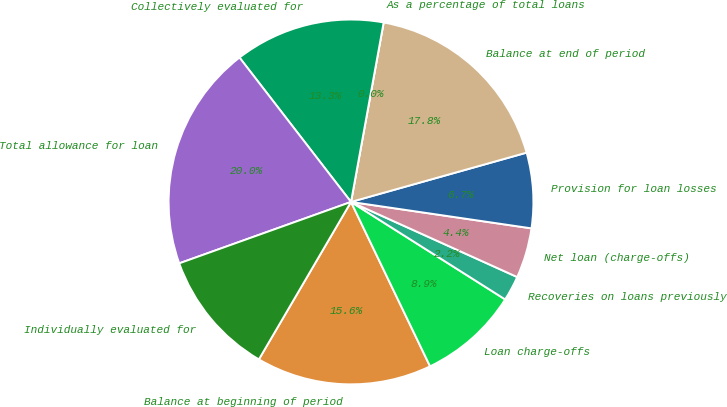<chart> <loc_0><loc_0><loc_500><loc_500><pie_chart><fcel>Balance at beginning of period<fcel>Loan charge-offs<fcel>Recoveries on loans previously<fcel>Net loan (charge-offs)<fcel>Provision for loan losses<fcel>Balance at end of period<fcel>As a percentage of total loans<fcel>Collectively evaluated for<fcel>Total allowance for loan<fcel>Individually evaluated for<nl><fcel>15.56%<fcel>8.89%<fcel>2.22%<fcel>4.44%<fcel>6.67%<fcel>17.78%<fcel>0.0%<fcel>13.33%<fcel>20.0%<fcel>11.11%<nl></chart> 